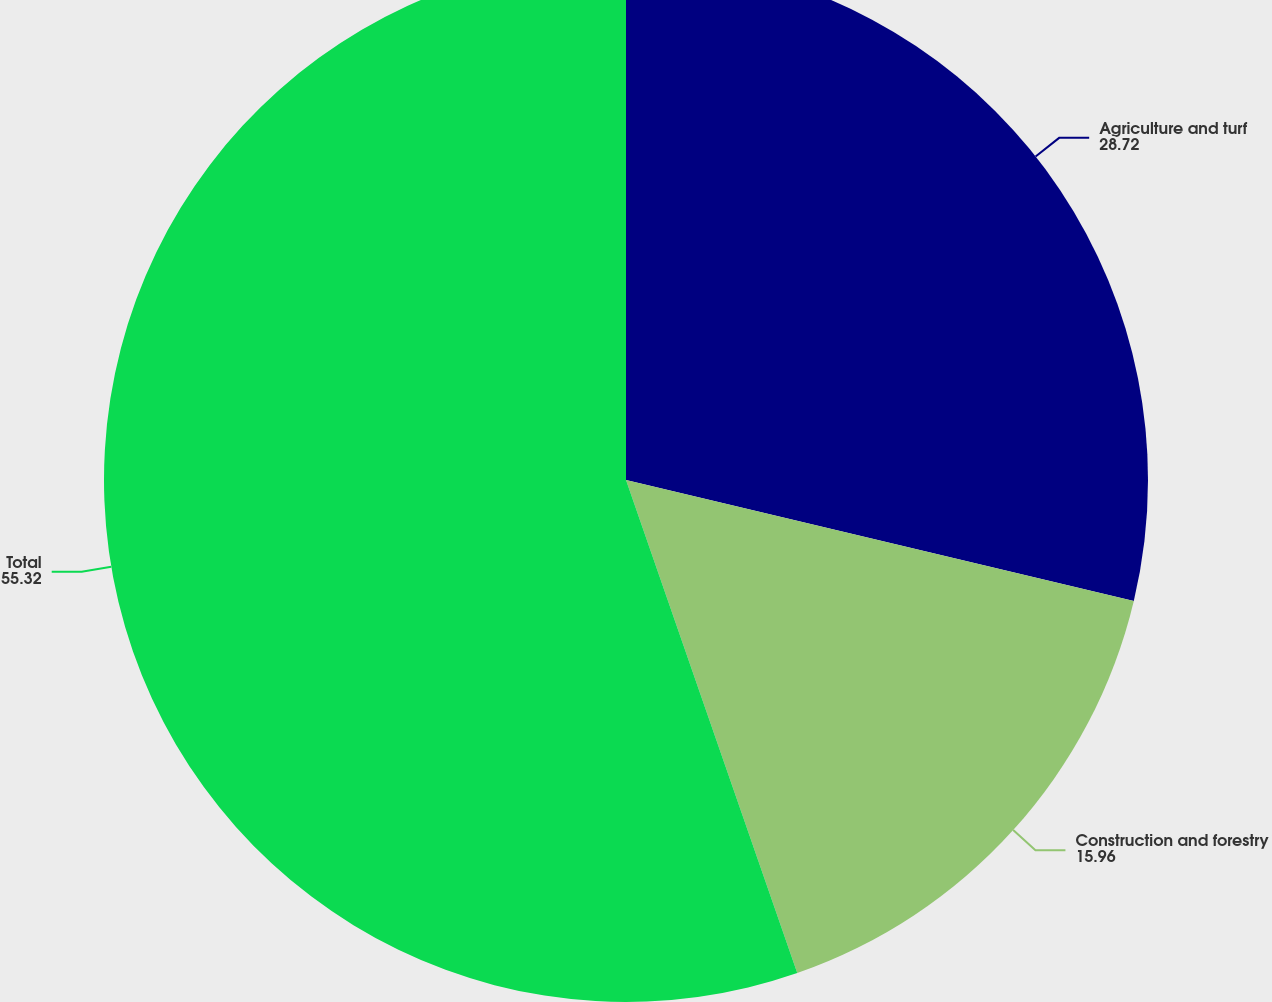<chart> <loc_0><loc_0><loc_500><loc_500><pie_chart><fcel>Agriculture and turf<fcel>Construction and forestry<fcel>Total<nl><fcel>28.72%<fcel>15.96%<fcel>55.32%<nl></chart> 